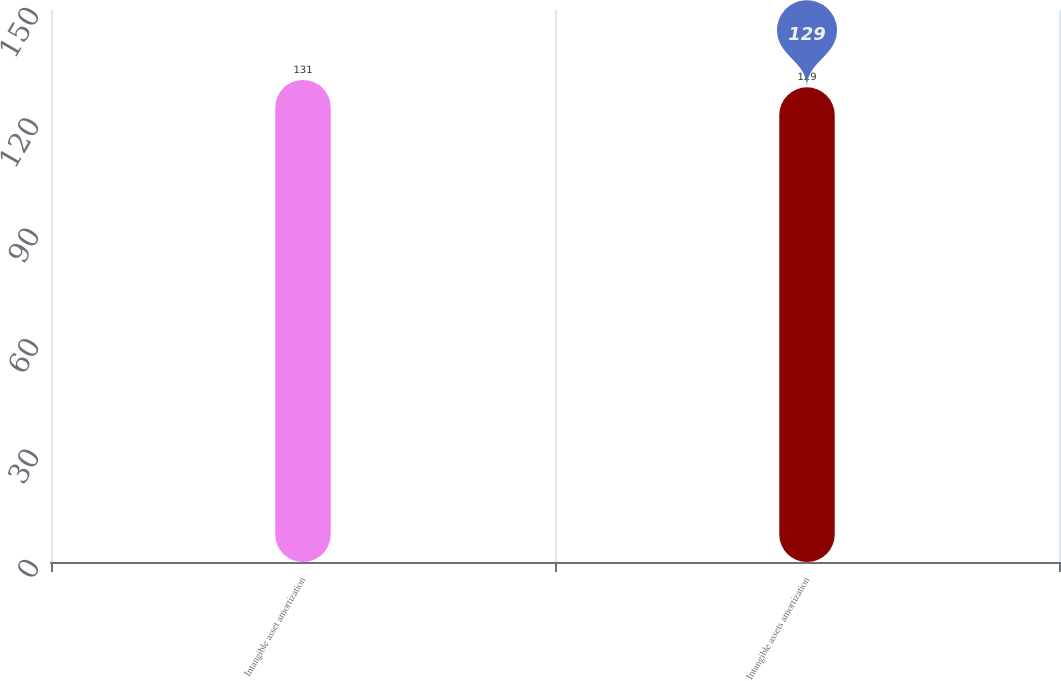Convert chart to OTSL. <chart><loc_0><loc_0><loc_500><loc_500><bar_chart><fcel>Intangible asset amortization<fcel>Intangible assets amortization<nl><fcel>131<fcel>129<nl></chart> 